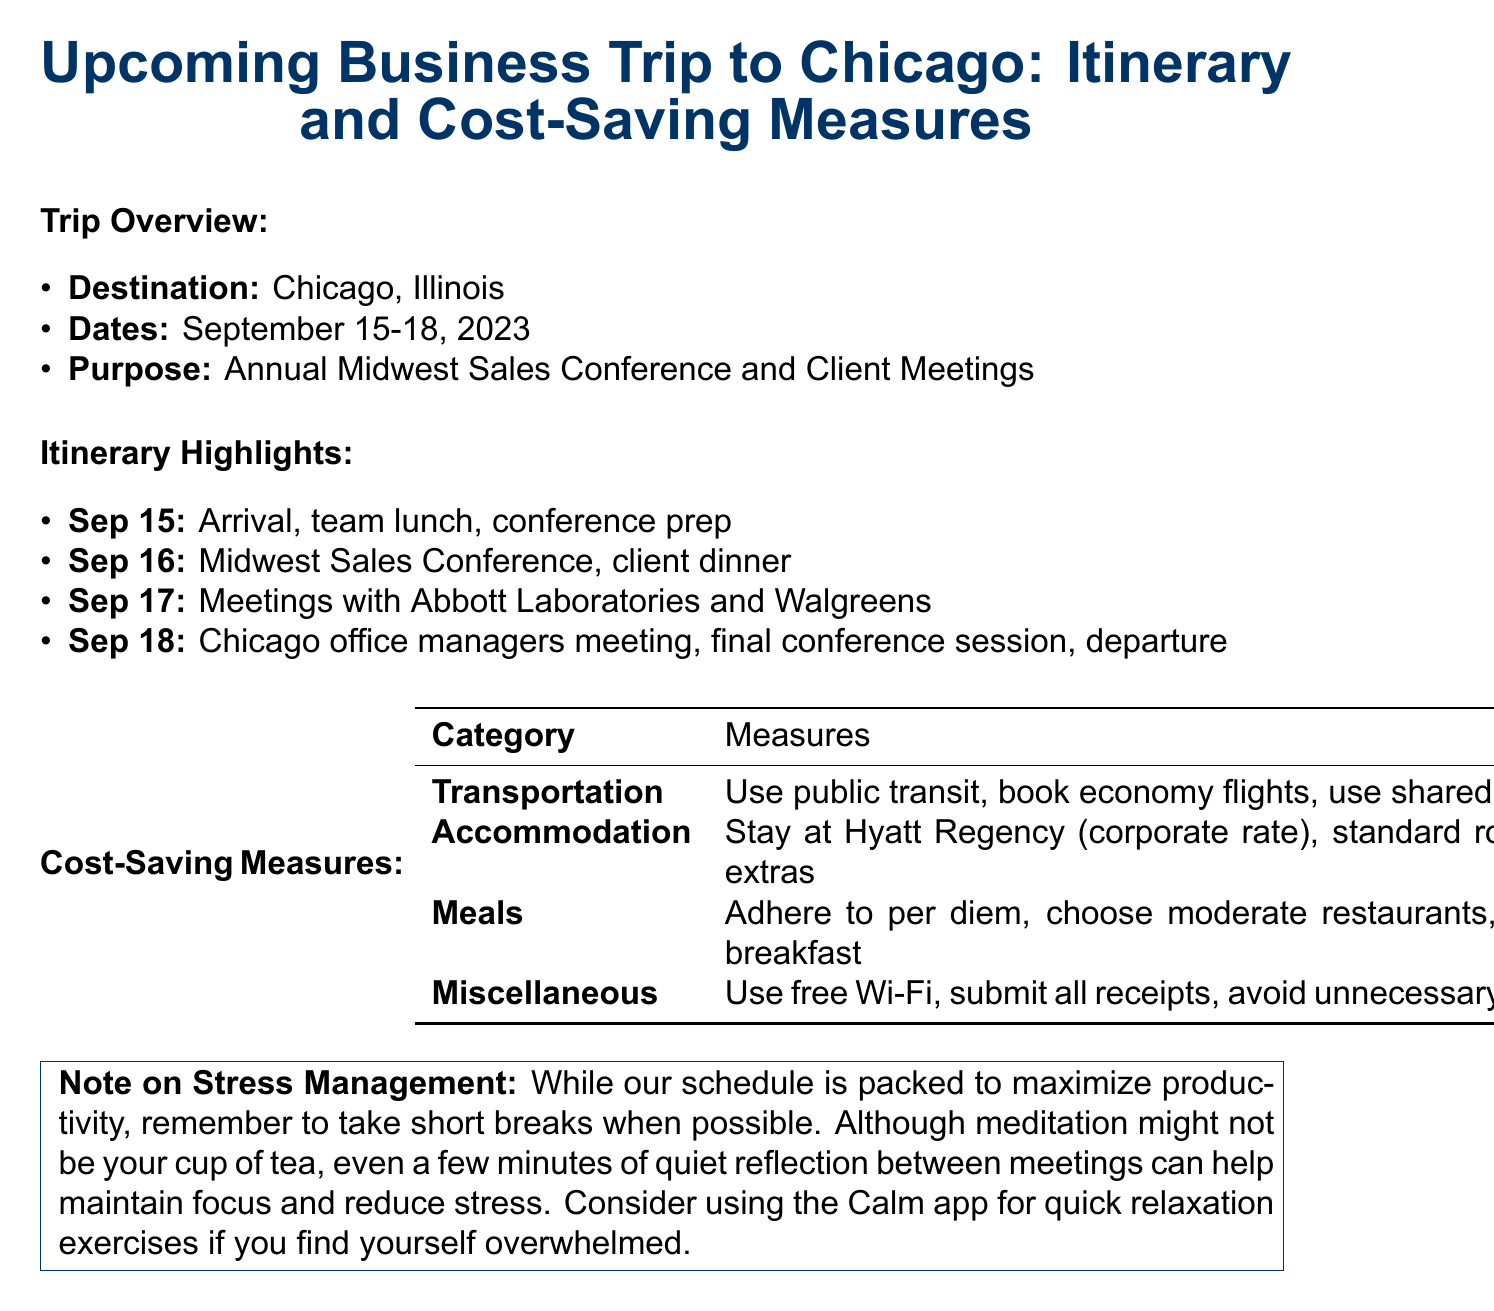What are the trip dates? The trip dates are noted in the trip overview section of the document.
Answer: September 15-18, 2023 Where will the Midwest Sales Conference be held? The location of the conference is specified in the itinerary section.
Answer: McCormick Place What hotel will be used for accommodation? The accommodation details are provided in the cost-saving measures section.
Answer: Hyatt Regency Chicago What is the purpose of the trip? The purpose is clearly outlined in the trip overview part of the document.
Answer: Annual Midwest Sales Conference and Client Meetings What cost-saving measure is suggested for transportation? The measures for cost saving in transportation are listed.
Answer: Use public transportation (CTA) instead of taxis How long is the client meeting with Abbott Laboratories? The duration of the meeting is described in the itinerary section.
Answer: 2 hours What is one way to manage stress mentioned in the memo? The document includes suggestions for stress management.
Answer: Take short breaks Which restaurant is mentioned for the networking dinner? The name of the restaurant for the dinner is specified in the itinerary.
Answer: Giordano's Pizza What time does the trip start? The starting time is mentioned in the itinerary for the first day.
Answer: 10:30 AM 